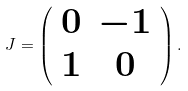<formula> <loc_0><loc_0><loc_500><loc_500>J = \left ( \begin{array} { c c } 0 & - 1 \\ 1 & 0 \end{array} \right ) .</formula> 